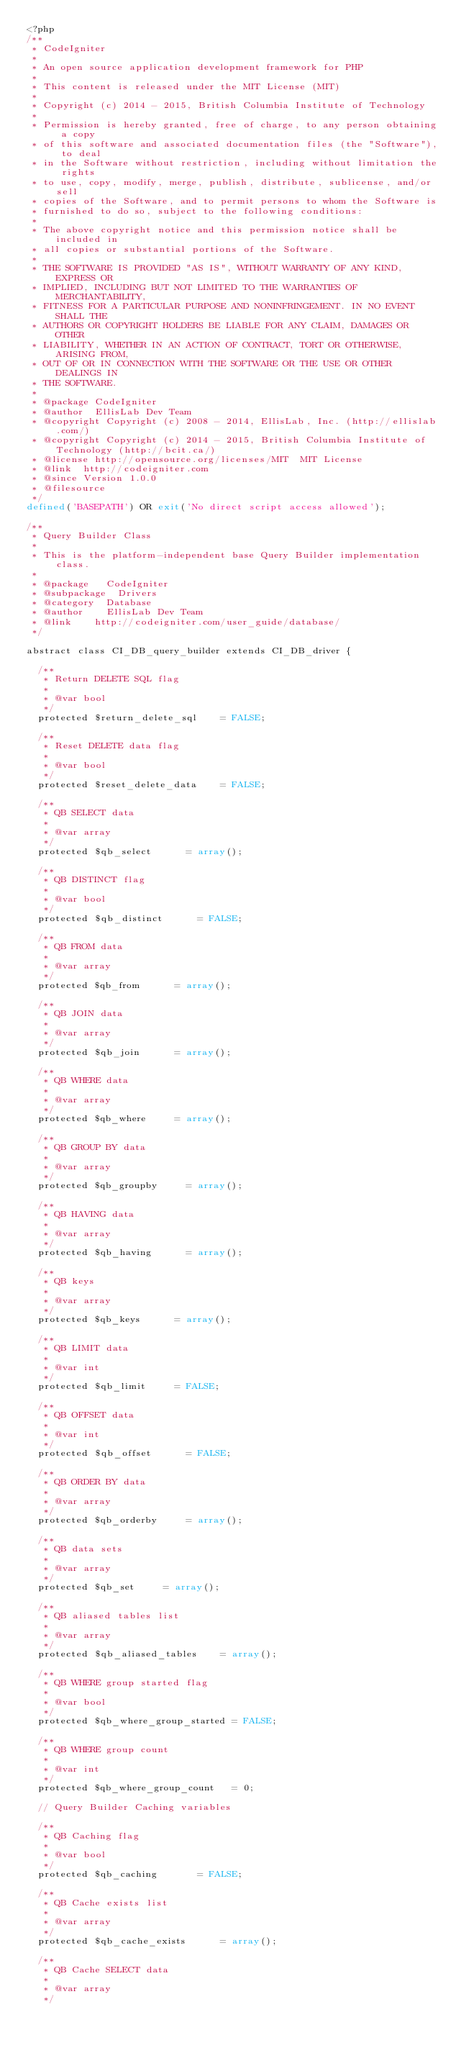Convert code to text. <code><loc_0><loc_0><loc_500><loc_500><_PHP_><?php
/**
 * CodeIgniter
 *
 * An open source application development framework for PHP
 *
 * This content is released under the MIT License (MIT)
 *
 * Copyright (c) 2014 - 2015, British Columbia Institute of Technology
 *
 * Permission is hereby granted, free of charge, to any person obtaining a copy
 * of this software and associated documentation files (the "Software"), to deal
 * in the Software without restriction, including without limitation the rights
 * to use, copy, modify, merge, publish, distribute, sublicense, and/or sell
 * copies of the Software, and to permit persons to whom the Software is
 * furnished to do so, subject to the following conditions:
 *
 * The above copyright notice and this permission notice shall be included in
 * all copies or substantial portions of the Software.
 *
 * THE SOFTWARE IS PROVIDED "AS IS", WITHOUT WARRANTY OF ANY KIND, EXPRESS OR
 * IMPLIED, INCLUDING BUT NOT LIMITED TO THE WARRANTIES OF MERCHANTABILITY,
 * FITNESS FOR A PARTICULAR PURPOSE AND NONINFRINGEMENT. IN NO EVENT SHALL THE
 * AUTHORS OR COPYRIGHT HOLDERS BE LIABLE FOR ANY CLAIM, DAMAGES OR OTHER
 * LIABILITY, WHETHER IN AN ACTION OF CONTRACT, TORT OR OTHERWISE, ARISING FROM,
 * OUT OF OR IN CONNECTION WITH THE SOFTWARE OR THE USE OR OTHER DEALINGS IN
 * THE SOFTWARE.
 *
 * @package	CodeIgniter
 * @author	EllisLab Dev Team
 * @copyright	Copyright (c) 2008 - 2014, EllisLab, Inc. (http://ellislab.com/)
 * @copyright	Copyright (c) 2014 - 2015, British Columbia Institute of Technology (http://bcit.ca/)
 * @license	http://opensource.org/licenses/MIT	MIT License
 * @link	http://codeigniter.com
 * @since	Version 1.0.0
 * @filesource
 */
defined('BASEPATH') OR exit('No direct script access allowed');

/**
 * Query Builder Class
 *
 * This is the platform-independent base Query Builder implementation class.
 *
 * @package		CodeIgniter
 * @subpackage	Drivers
 * @category	Database
 * @author		EllisLab Dev Team
 * @link		http://codeigniter.com/user_guide/database/
 */

abstract class CI_DB_query_builder extends CI_DB_driver {

	/**
	 * Return DELETE SQL flag
	 *
	 * @var	bool
	 */
	protected $return_delete_sql		= FALSE;

	/**
	 * Reset DELETE data flag
	 *
	 * @var	bool
	 */
	protected $reset_delete_data		= FALSE;

	/**
	 * QB SELECT data
	 *
	 * @var	array
	 */
	protected $qb_select			= array();

	/**
	 * QB DISTINCT flag
	 *
	 * @var	bool
	 */
	protected $qb_distinct			= FALSE;

	/**
	 * QB FROM data
	 *
	 * @var	array
	 */
	protected $qb_from			= array();

	/**
	 * QB JOIN data
	 *
	 * @var	array
	 */
	protected $qb_join			= array();

	/**
	 * QB WHERE data
	 *
	 * @var	array
	 */
	protected $qb_where			= array();

	/**
	 * QB GROUP BY data
	 *
	 * @var	array
	 */
	protected $qb_groupby			= array();

	/**
	 * QB HAVING data
	 *
	 * @var	array
	 */
	protected $qb_having			= array();

	/**
	 * QB keys
	 *
	 * @var	array
	 */
	protected $qb_keys			= array();

	/**
	 * QB LIMIT data
	 *
	 * @var	int
	 */
	protected $qb_limit			= FALSE;

	/**
	 * QB OFFSET data
	 *
	 * @var	int
	 */
	protected $qb_offset			= FALSE;

	/**
	 * QB ORDER BY data
	 *
	 * @var	array
	 */
	protected $qb_orderby			= array();

	/**
	 * QB data sets
	 *
	 * @var	array
	 */
	protected $qb_set			= array();

	/**
	 * QB aliased tables list
	 *
	 * @var	array
	 */
	protected $qb_aliased_tables		= array();

	/**
	 * QB WHERE group started flag
	 *
	 * @var	bool
	 */
	protected $qb_where_group_started	= FALSE;

	/**
	 * QB WHERE group count
	 *
	 * @var	int
	 */
	protected $qb_where_group_count		= 0;

	// Query Builder Caching variables

	/**
	 * QB Caching flag
	 *
	 * @var	bool
	 */
	protected $qb_caching				= FALSE;

	/**
	 * QB Cache exists list
	 *
	 * @var	array
	 */
	protected $qb_cache_exists			= array();

	/**
	 * QB Cache SELECT data
	 *
	 * @var	array
	 */</code> 